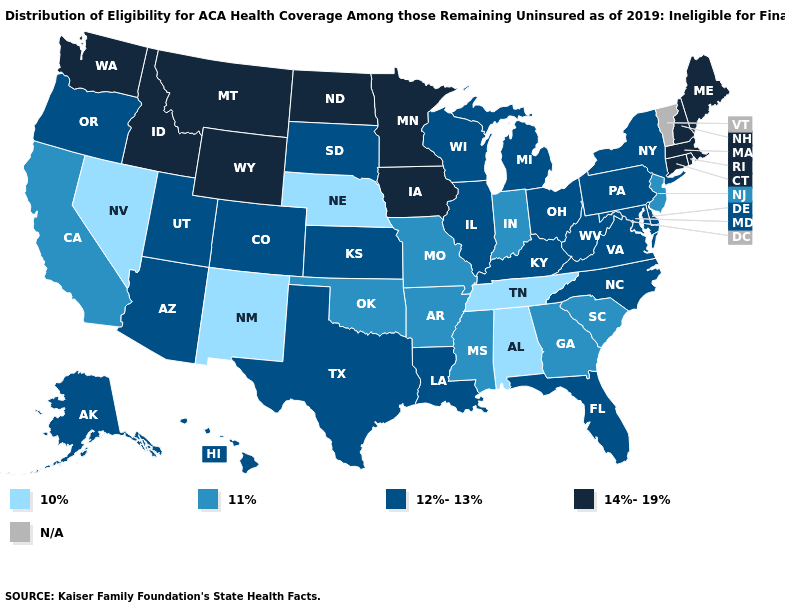Does West Virginia have the highest value in the South?
Concise answer only. Yes. Which states have the lowest value in the Northeast?
Give a very brief answer. New Jersey. What is the value of Illinois?
Write a very short answer. 12%-13%. Name the states that have a value in the range 12%-13%?
Quick response, please. Alaska, Arizona, Colorado, Delaware, Florida, Hawaii, Illinois, Kansas, Kentucky, Louisiana, Maryland, Michigan, New York, North Carolina, Ohio, Oregon, Pennsylvania, South Dakota, Texas, Utah, Virginia, West Virginia, Wisconsin. Among the states that border Florida , which have the highest value?
Quick response, please. Georgia. Name the states that have a value in the range N/A?
Quick response, please. Vermont. Does the first symbol in the legend represent the smallest category?
Keep it brief. Yes. How many symbols are there in the legend?
Keep it brief. 5. Which states have the highest value in the USA?
Give a very brief answer. Connecticut, Idaho, Iowa, Maine, Massachusetts, Minnesota, Montana, New Hampshire, North Dakota, Rhode Island, Washington, Wyoming. What is the value of New Hampshire?
Keep it brief. 14%-19%. What is the value of Washington?
Keep it brief. 14%-19%. Name the states that have a value in the range 12%-13%?
Short answer required. Alaska, Arizona, Colorado, Delaware, Florida, Hawaii, Illinois, Kansas, Kentucky, Louisiana, Maryland, Michigan, New York, North Carolina, Ohio, Oregon, Pennsylvania, South Dakota, Texas, Utah, Virginia, West Virginia, Wisconsin. Does Arkansas have the lowest value in the USA?
Answer briefly. No. Does Mississippi have the highest value in the South?
Answer briefly. No. Name the states that have a value in the range 10%?
Quick response, please. Alabama, Nebraska, Nevada, New Mexico, Tennessee. 